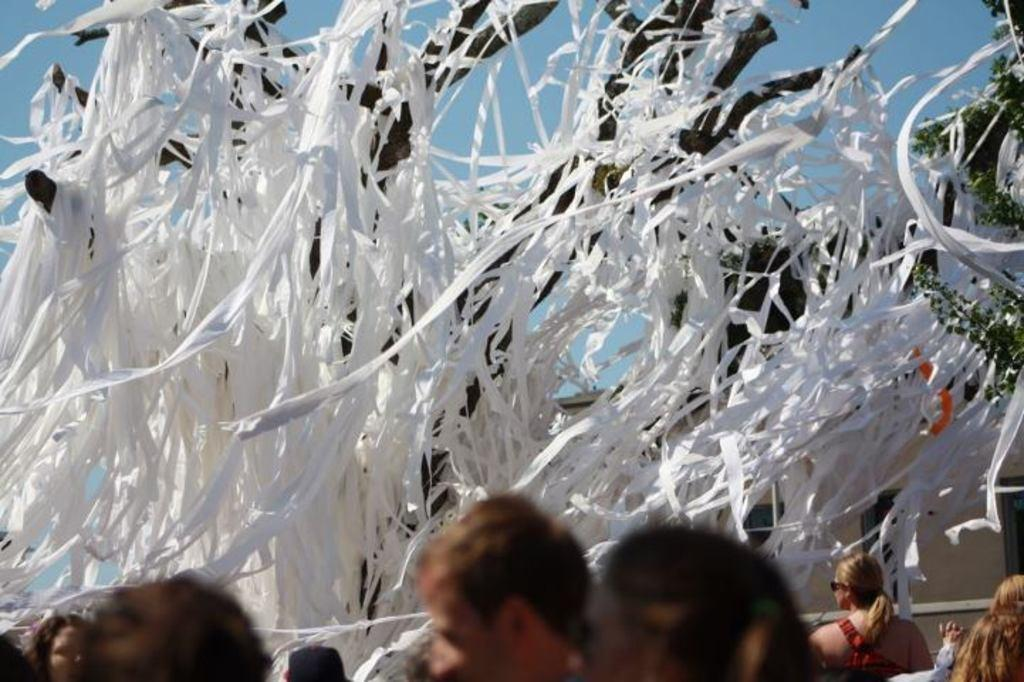What color are the objects in the image? The objects in the image are white colored. What material can be seen in the image? Wood is visible in the image. Who or what is present in the image? There are people in the image. What can be seen on the right side of the image? There is a tree on the right side of the image. What is visible in the background of the image? The sky is visible in the image. What type of apparatus is being used by the people in the image? There is no apparatus visible in the image; it only shows white colored objects, wood, people, a tree, and the sky. 